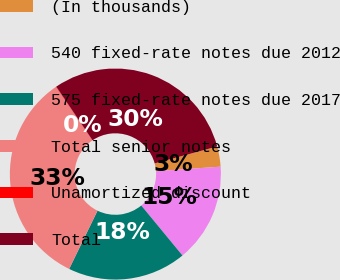Convert chart to OTSL. <chart><loc_0><loc_0><loc_500><loc_500><pie_chart><fcel>(In thousands)<fcel>540 fixed-rate notes due 2012<fcel>575 fixed-rate notes due 2017<fcel>Total senior notes<fcel>Unamortized discount<fcel>Total<nl><fcel>3.09%<fcel>15.15%<fcel>18.18%<fcel>33.27%<fcel>0.06%<fcel>30.25%<nl></chart> 